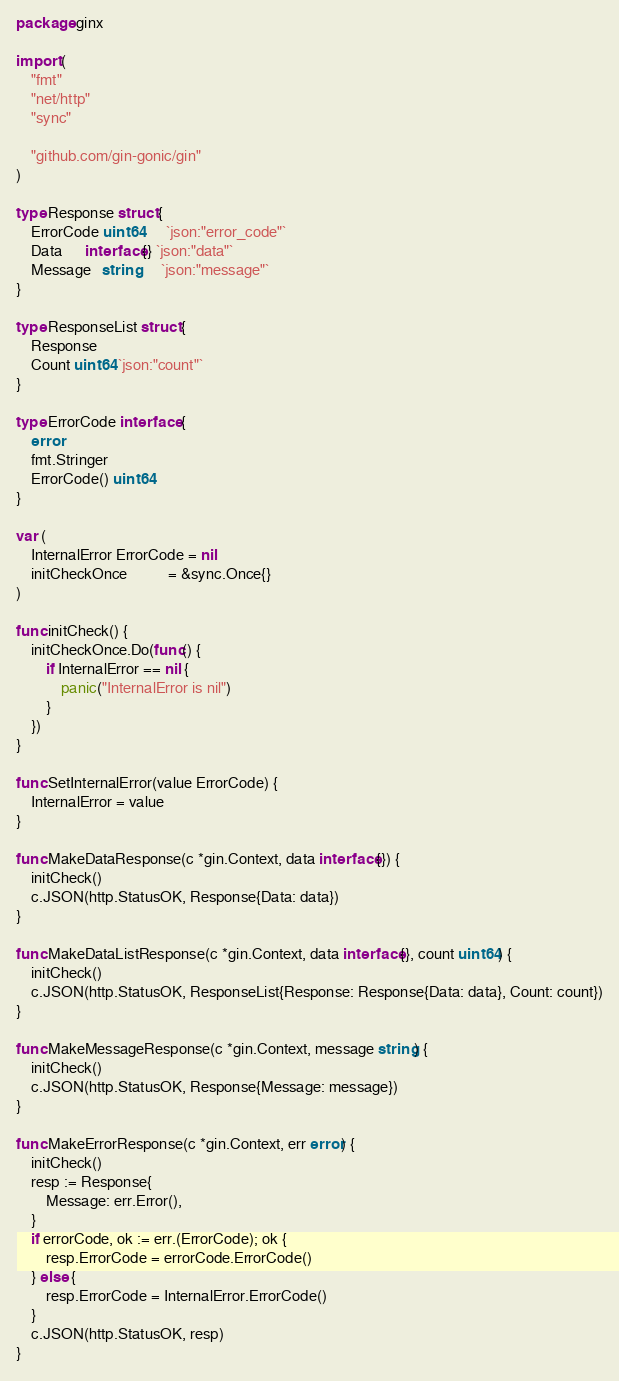<code> <loc_0><loc_0><loc_500><loc_500><_Go_>package ginx

import (
	"fmt"
	"net/http"
	"sync"

	"github.com/gin-gonic/gin"
)

type Response struct {
	ErrorCode uint64      `json:"error_code"`
	Data      interface{} `json:"data"`
	Message   string      `json:"message"`
}

type ResponseList struct {
	Response
	Count uint64 `json:"count"`
}

type ErrorCode interface {
	error
	fmt.Stringer
	ErrorCode() uint64
}

var (
	InternalError ErrorCode = nil
	initCheckOnce           = &sync.Once{}
)

func initCheck() {
	initCheckOnce.Do(func() {
		if InternalError == nil {
			panic("InternalError is nil")
		}
	})
}

func SetInternalError(value ErrorCode) {
	InternalError = value
}

func MakeDataResponse(c *gin.Context, data interface{}) {
	initCheck()
	c.JSON(http.StatusOK, Response{Data: data})
}

func MakeDataListResponse(c *gin.Context, data interface{}, count uint64) {
	initCheck()
	c.JSON(http.StatusOK, ResponseList{Response: Response{Data: data}, Count: count})
}

func MakeMessageResponse(c *gin.Context, message string) {
	initCheck()
	c.JSON(http.StatusOK, Response{Message: message})
}

func MakeErrorResponse(c *gin.Context, err error) {
	initCheck()
	resp := Response{
		Message: err.Error(),
	}
	if errorCode, ok := err.(ErrorCode); ok {
		resp.ErrorCode = errorCode.ErrorCode()
	} else {
		resp.ErrorCode = InternalError.ErrorCode()
	}
	c.JSON(http.StatusOK, resp)
}
</code> 